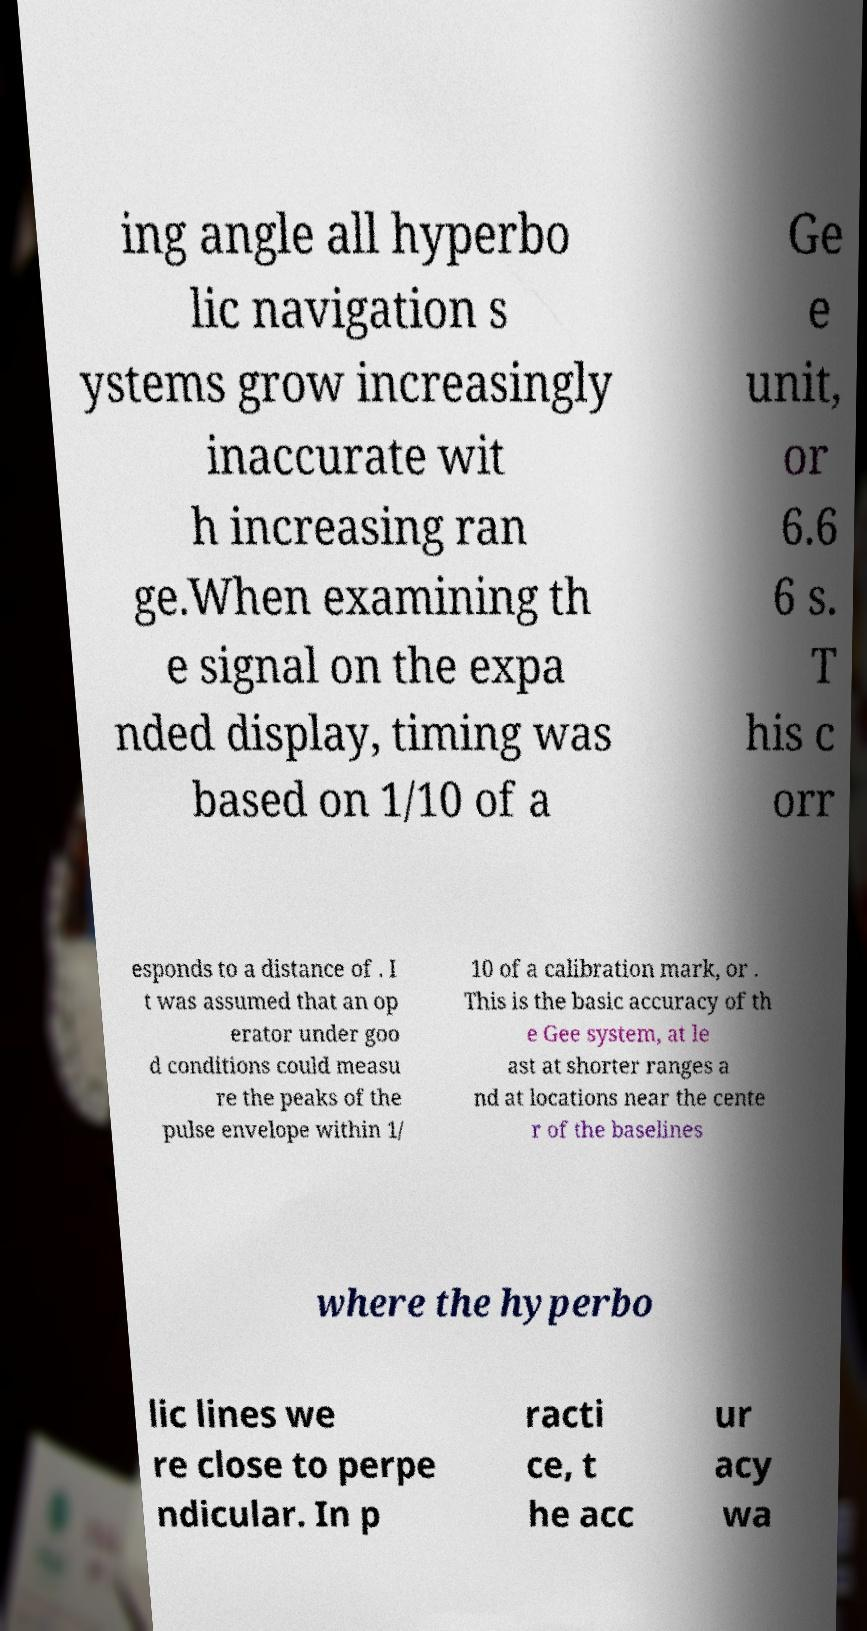Can you read and provide the text displayed in the image?This photo seems to have some interesting text. Can you extract and type it out for me? ing angle all hyperbo lic navigation s ystems grow increasingly inaccurate wit h increasing ran ge.When examining th e signal on the expa nded display, timing was based on 1/10 of a Ge e unit, or 6.6 6 s. T his c orr esponds to a distance of . I t was assumed that an op erator under goo d conditions could measu re the peaks of the pulse envelope within 1/ 10 of a calibration mark, or . This is the basic accuracy of th e Gee system, at le ast at shorter ranges a nd at locations near the cente r of the baselines where the hyperbo lic lines we re close to perpe ndicular. In p racti ce, t he acc ur acy wa 